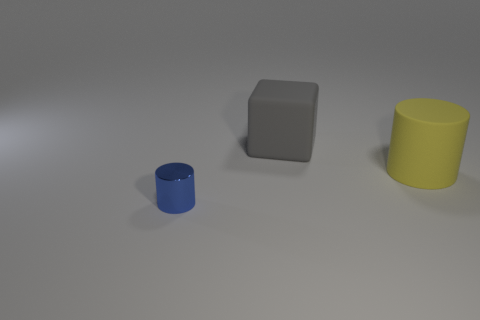Are there any other things that have the same size as the blue thing?
Give a very brief answer. No. Is the shape of the thing that is in front of the big yellow matte cylinder the same as the thing that is to the right of the large gray thing?
Provide a succinct answer. Yes. There is a cylinder to the right of the cylinder to the left of the cylinder behind the blue metal object; what is its size?
Ensure brevity in your answer.  Large. There is a cylinder that is on the left side of the rubber cylinder; what size is it?
Offer a terse response. Small. There is a big thing in front of the gray rubber cube; what is its material?
Offer a terse response. Rubber. What number of red objects are large balls or cylinders?
Your answer should be very brief. 0. Do the yellow thing and the cylinder that is in front of the yellow rubber object have the same material?
Give a very brief answer. No. Is the number of things behind the tiny blue shiny thing the same as the number of big yellow cylinders that are behind the gray thing?
Give a very brief answer. No. Is the size of the blue thing the same as the object that is to the right of the large block?
Offer a very short reply. No. Is the number of tiny metal objects that are in front of the large gray thing greater than the number of tiny gray blocks?
Your answer should be compact. Yes. 